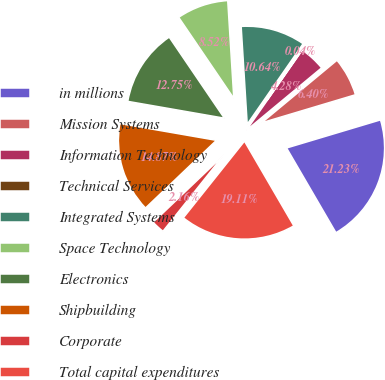Convert chart. <chart><loc_0><loc_0><loc_500><loc_500><pie_chart><fcel>in millions<fcel>Mission Systems<fcel>Information Technology<fcel>Technical Services<fcel>Integrated Systems<fcel>Space Technology<fcel>Electronics<fcel>Shipbuilding<fcel>Corporate<fcel>Total capital expenditures<nl><fcel>21.23%<fcel>6.4%<fcel>4.28%<fcel>0.04%<fcel>10.64%<fcel>8.52%<fcel>12.75%<fcel>14.87%<fcel>2.16%<fcel>19.11%<nl></chart> 